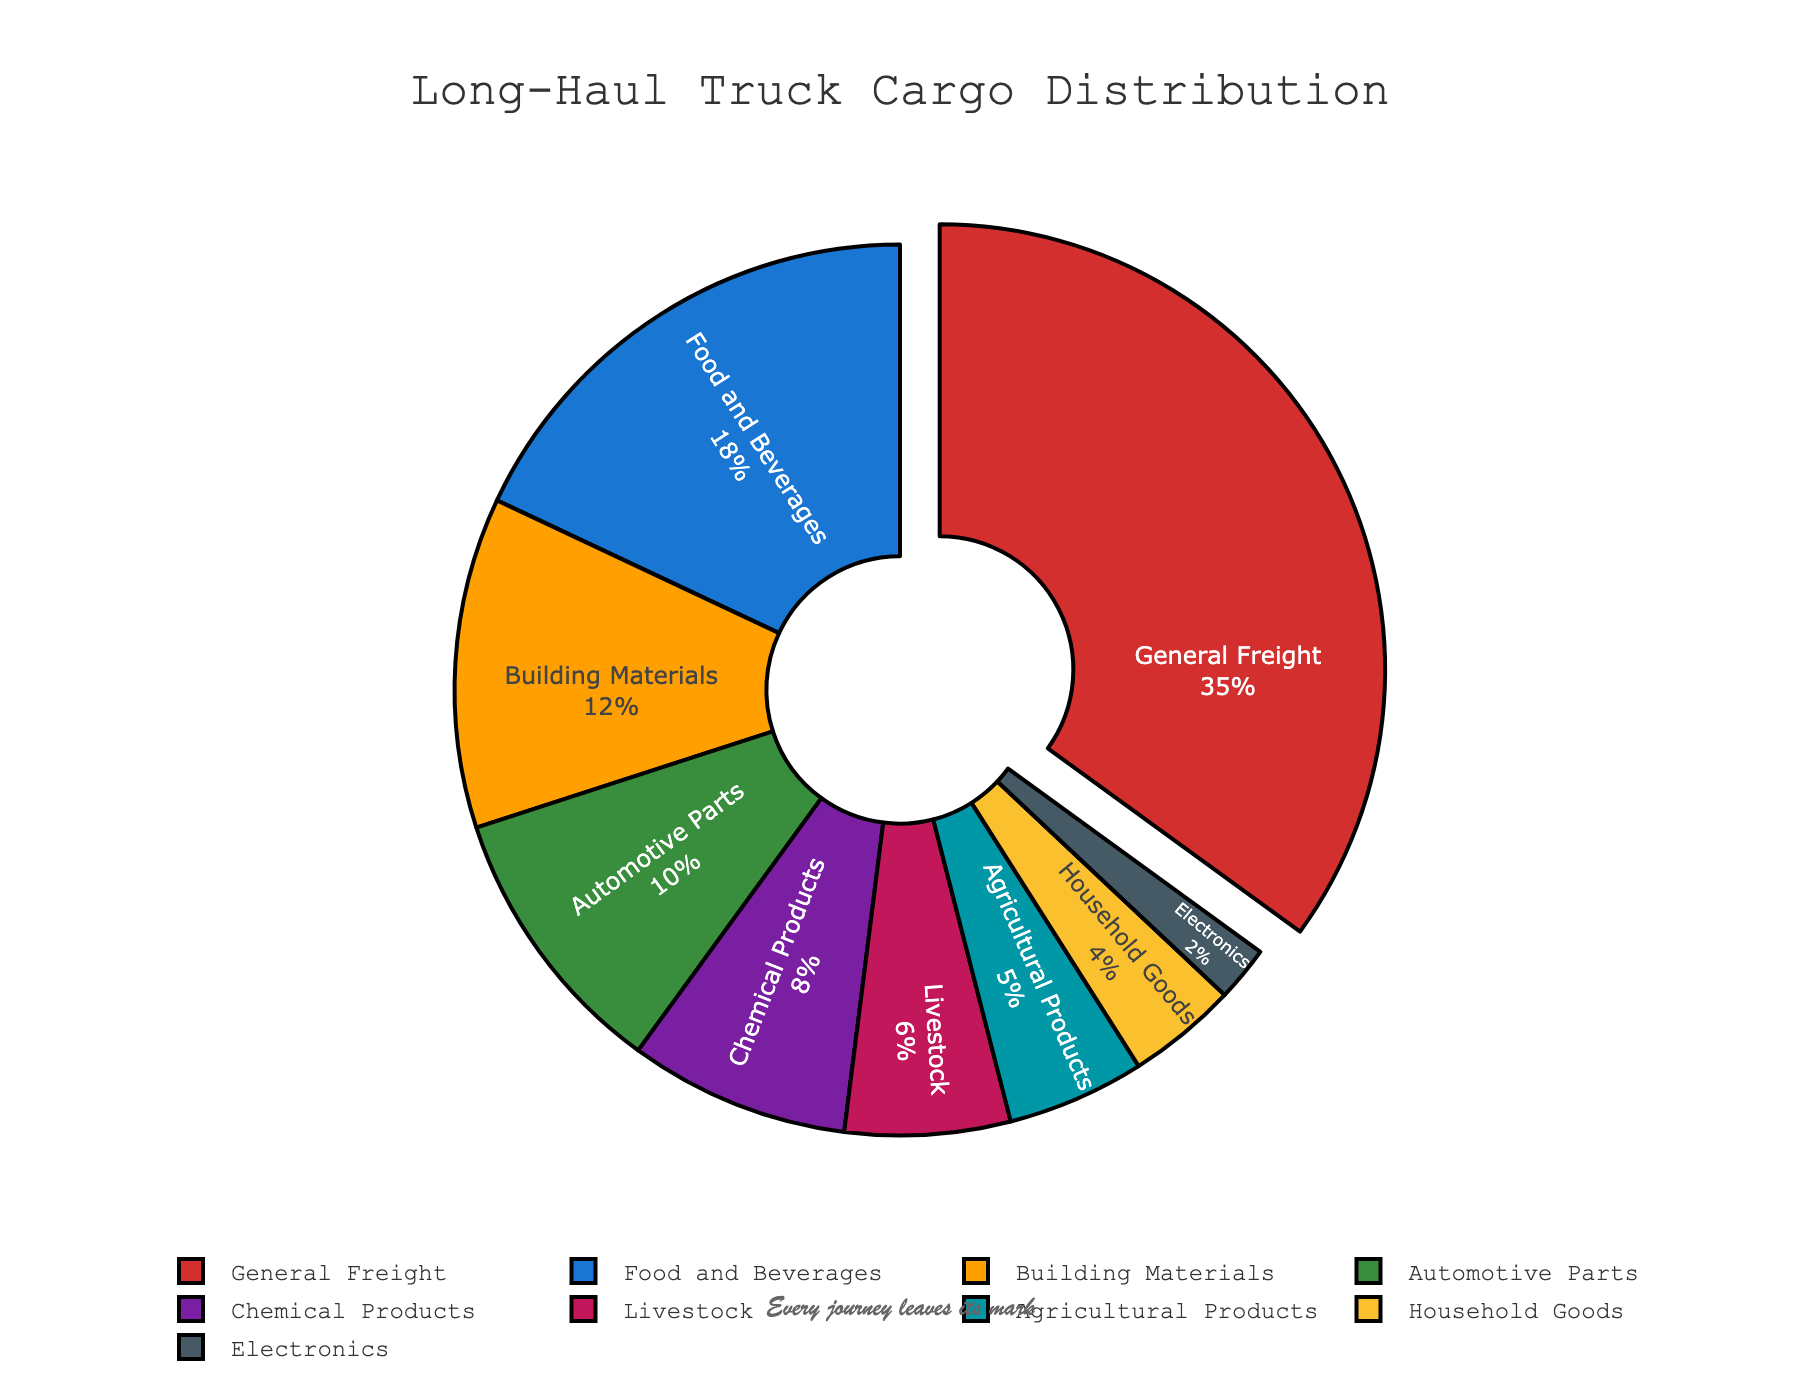Which type of cargo takes up the largest percentage? The pie chart highlights the largest slice, which is "General Freight". It also has a percentage label of 35%, indicating it is the largest.
Answer: General Freight How much more percentage of General Freight is transported compared to Chemical Products? General Freight has 35% and Chemical Products have 8%. The difference is calculated as 35% - 8%.
Answer: 27% What is the combined percentage of Food and Beverages and Building Materials? Food and Beverages is 18% and Building Materials is 12%. The combined percentage is 18% + 12%.
Answer: 30% How does the percentage of Automotive Parts compare to Livestock? Automotive Parts is 10% and Livestock is 6%. Therefore, Automotive Parts is greater than Livestock by 4%. 10% - 6% = 4%.
Answer: 4% Which types of cargo together make up less than 10% of the total percentage? The types of cargo below 10% are Chemical Products (8%), Livestock (6%), Agricultural Products (5%), Household Goods (4%), and Electronics (2%). These all together are under 10% individually.
Answer: Chemical Products, Livestock, Agricultural Products, Household Goods, Electronics What's the smallest percentage of cargo transported and what type it represents? The pie chart shows that Electronics have the smallest percentage at 2%.
Answer: Electronics If you sum the percentages of the two smallest cargo types, what do you get? The two smallest cargo percentages are Electronics (2%) and Household Goods (4%). Summing these gives 2% + 4%.
Answer: 6% Are the percentages of Food and Beverages closer to Automotive Parts or to Building Materials? Food and Beverages is at 18%, Automotive Parts at 10%, and Building Materials at 12%. The difference with Automotive Parts is 8% (18% - 10%) and the difference with Building Materials is 6% (18% - 12%). Since 6% is smaller than 8%, Food and Beverages is closer to Building Materials.
Answer: Building Materials Which cargo category, General Freight or Food and Beverages, has a higher percentage and by how much? General Freight has 35% and Food and Beverages has 18%. The difference is 35% - 18%.
Answer: 17% What proportion of the total percentage does General Freight represent if the total percentage is considered as 100%? The pie chart shows General Freight at 35%, representing 35 out of 100 or 35%.
Answer: 35% 